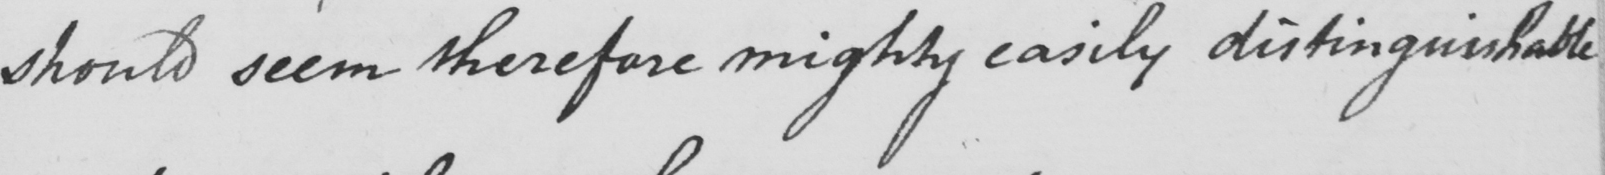Transcribe the text shown in this historical manuscript line. should seem therefore mighty easily distinguishable 